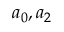Convert formula to latex. <formula><loc_0><loc_0><loc_500><loc_500>a _ { 0 } , a _ { 2 }</formula> 